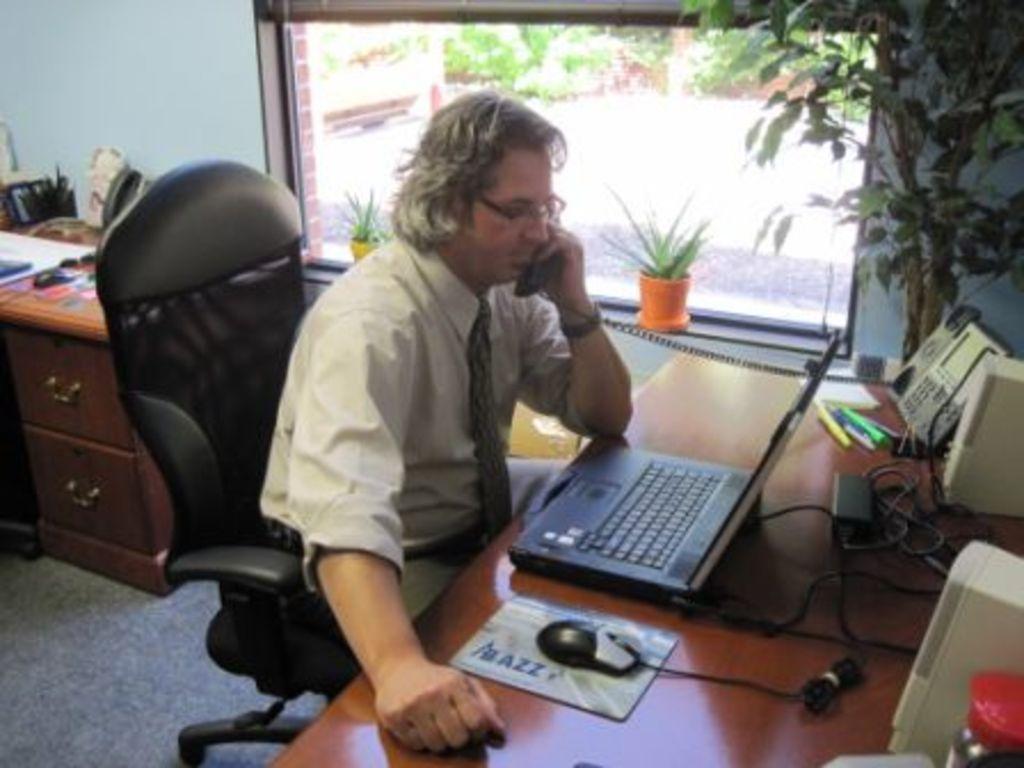Could you give a brief overview of what you see in this image? person sitting on the chair seeing laptop using phone beside there is tree,this glass and in back there is drawers. 